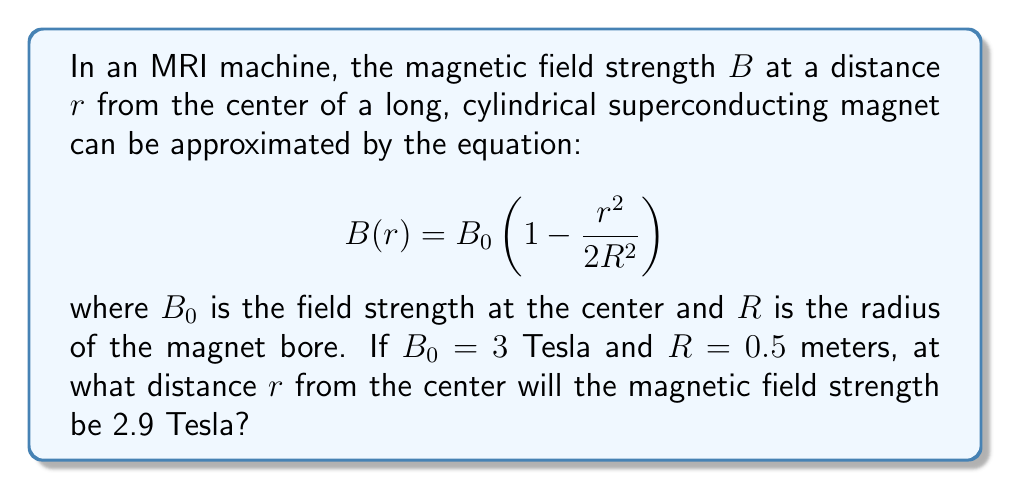What is the answer to this math problem? To solve this problem, we'll follow these steps:

1) We start with the given equation:
   $$B(r) = B_0 \left(1 - \frac{r^2}{2R^2}\right)$$

2) We know that $B(r) = 2.9$ T, $B_0 = 3$ T, and $R = 0.5$ m. Let's substitute these values:
   $$2.9 = 3 \left(1 - \frac{r^2}{2(0.5)^2}\right)$$

3) Simplify the right side:
   $$2.9 = 3 \left(1 - \frac{r^2}{0.5}\right)$$

4) Divide both sides by 3:
   $$\frac{2.9}{3} = 1 - \frac{r^2}{0.5}$$

5) Simplify:
   $$0.9667 = 1 - 2r^2$$

6) Subtract both sides from 1:
   $$0.0333 = 2r^2$$

7) Divide both sides by 2:
   $$0.01665 = r^2$$

8) Take the square root of both sides:
   $$r = \sqrt{0.01665} \approx 0.129$$

Therefore, the distance $r$ from the center where the magnetic field strength is 2.9 Tesla is approximately 0.129 meters.
Answer: $r \approx 0.129$ m 